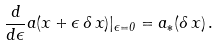Convert formula to latex. <formula><loc_0><loc_0><loc_500><loc_500>\frac { d } { d \epsilon } a ( { x } + \epsilon \, \delta \, { x } ) | _ { \epsilon = 0 } = { a _ { * } } ( \delta \, { x } ) \, .</formula> 